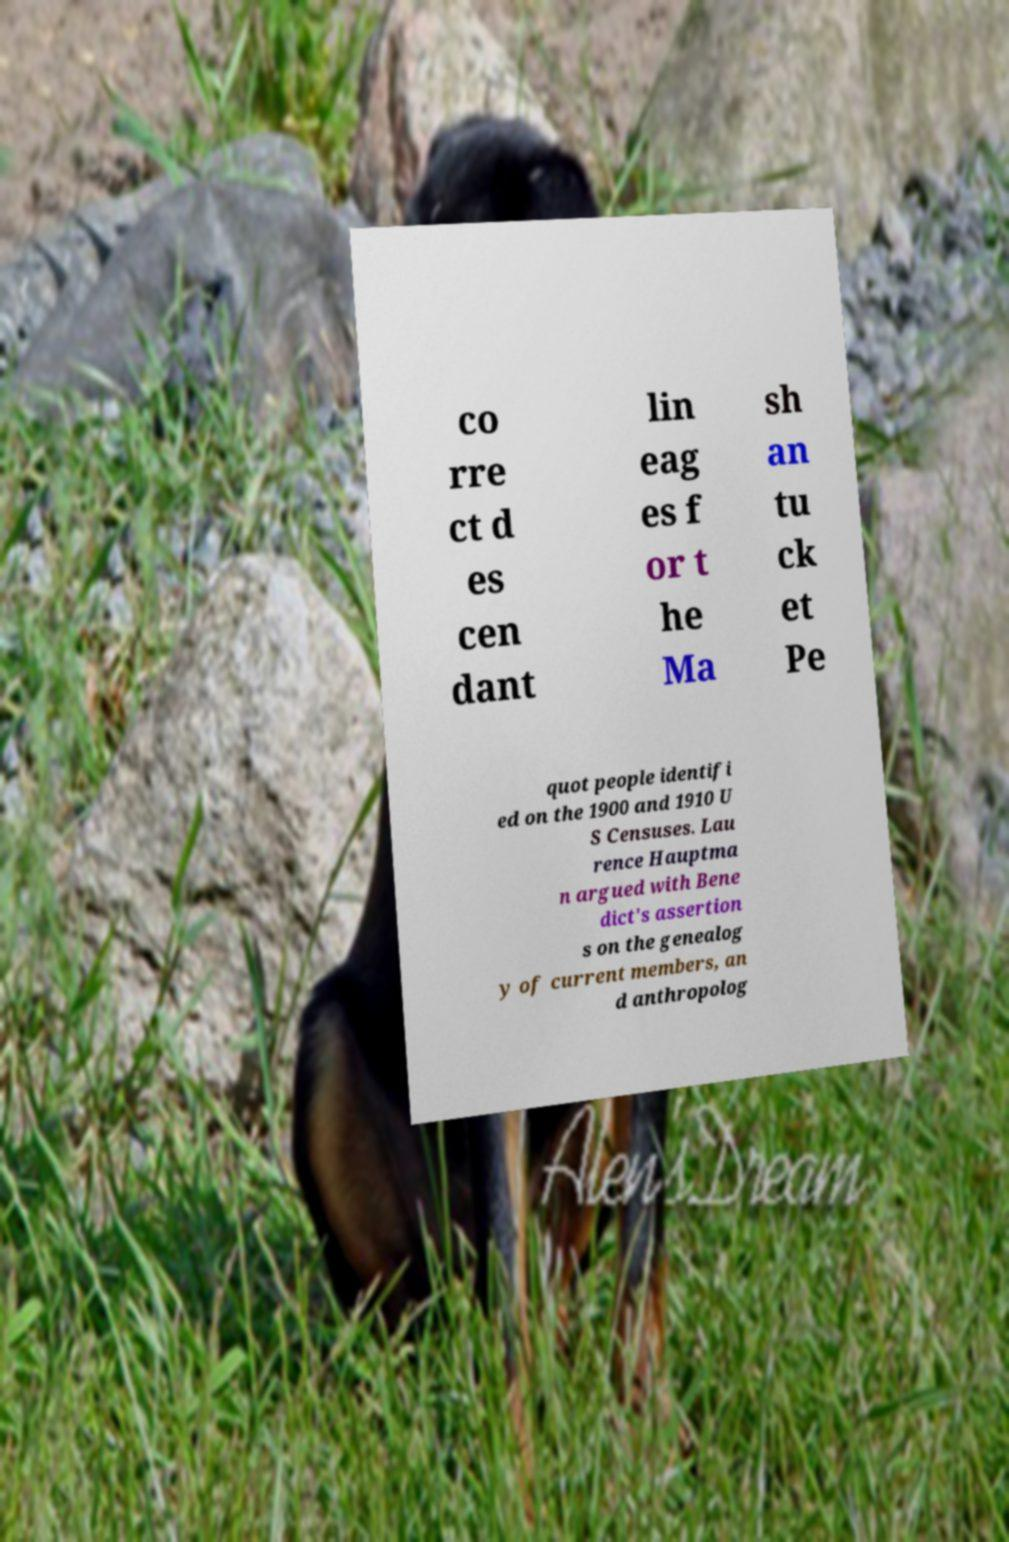For documentation purposes, I need the text within this image transcribed. Could you provide that? co rre ct d es cen dant lin eag es f or t he Ma sh an tu ck et Pe quot people identifi ed on the 1900 and 1910 U S Censuses. Lau rence Hauptma n argued with Bene dict's assertion s on the genealog y of current members, an d anthropolog 